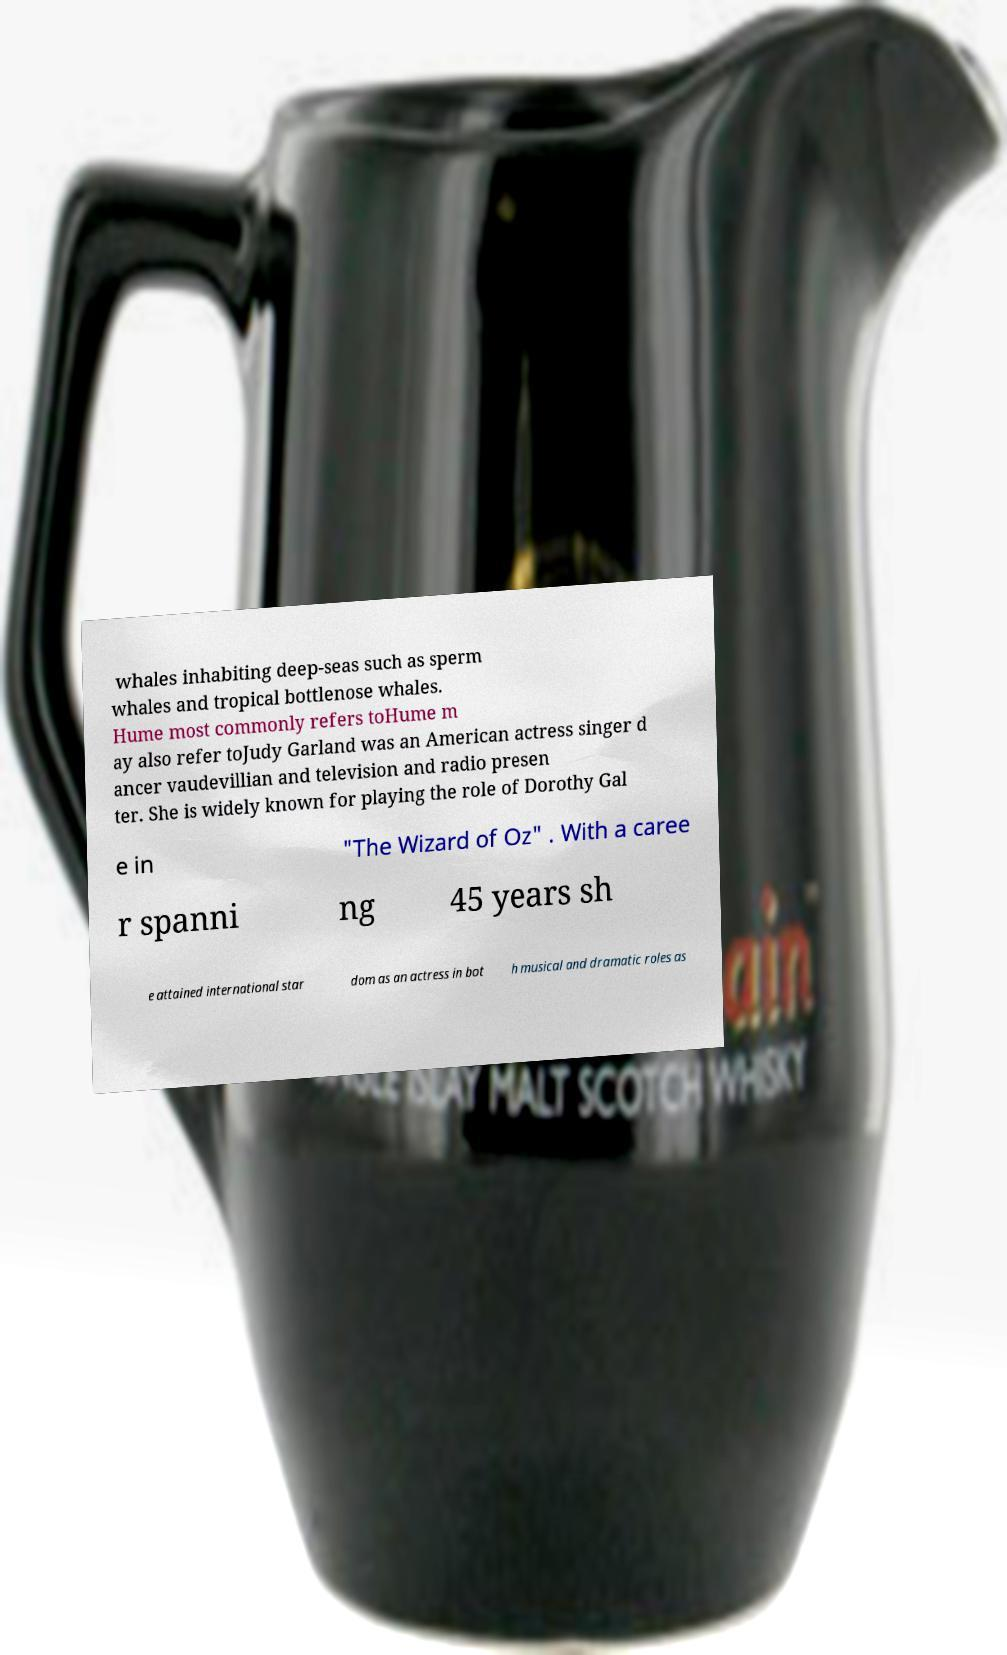I need the written content from this picture converted into text. Can you do that? whales inhabiting deep-seas such as sperm whales and tropical bottlenose whales. Hume most commonly refers toHume m ay also refer toJudy Garland was an American actress singer d ancer vaudevillian and television and radio presen ter. She is widely known for playing the role of Dorothy Gal e in "The Wizard of Oz" . With a caree r spanni ng 45 years sh e attained international star dom as an actress in bot h musical and dramatic roles as 